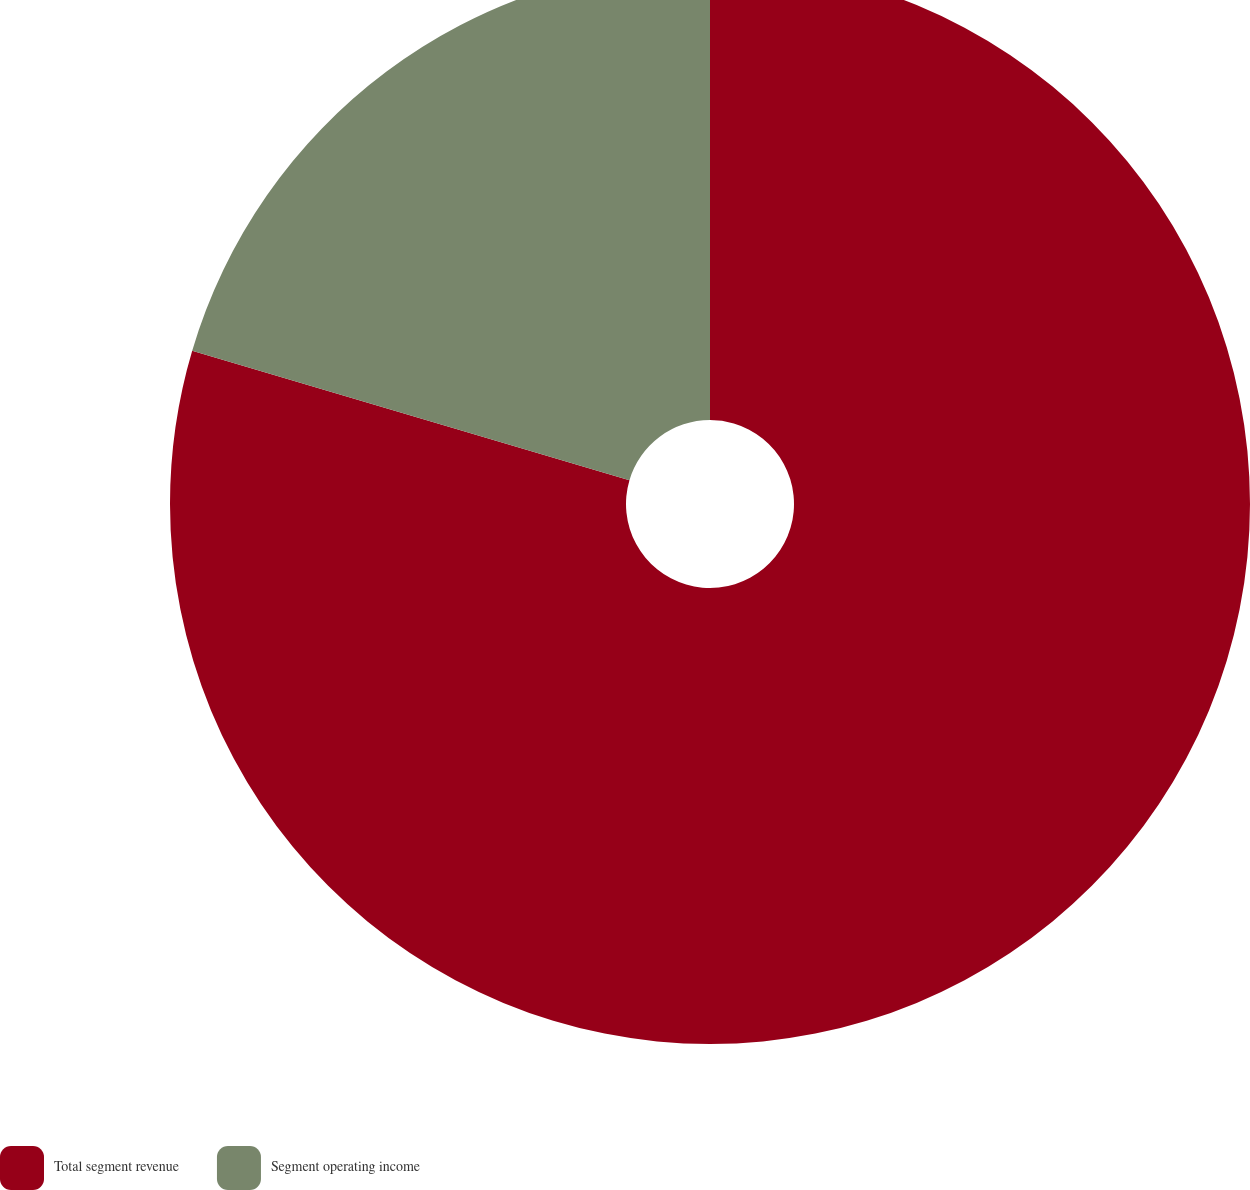Convert chart. <chart><loc_0><loc_0><loc_500><loc_500><pie_chart><fcel>Total segment revenue<fcel>Segment operating income<nl><fcel>79.58%<fcel>20.42%<nl></chart> 